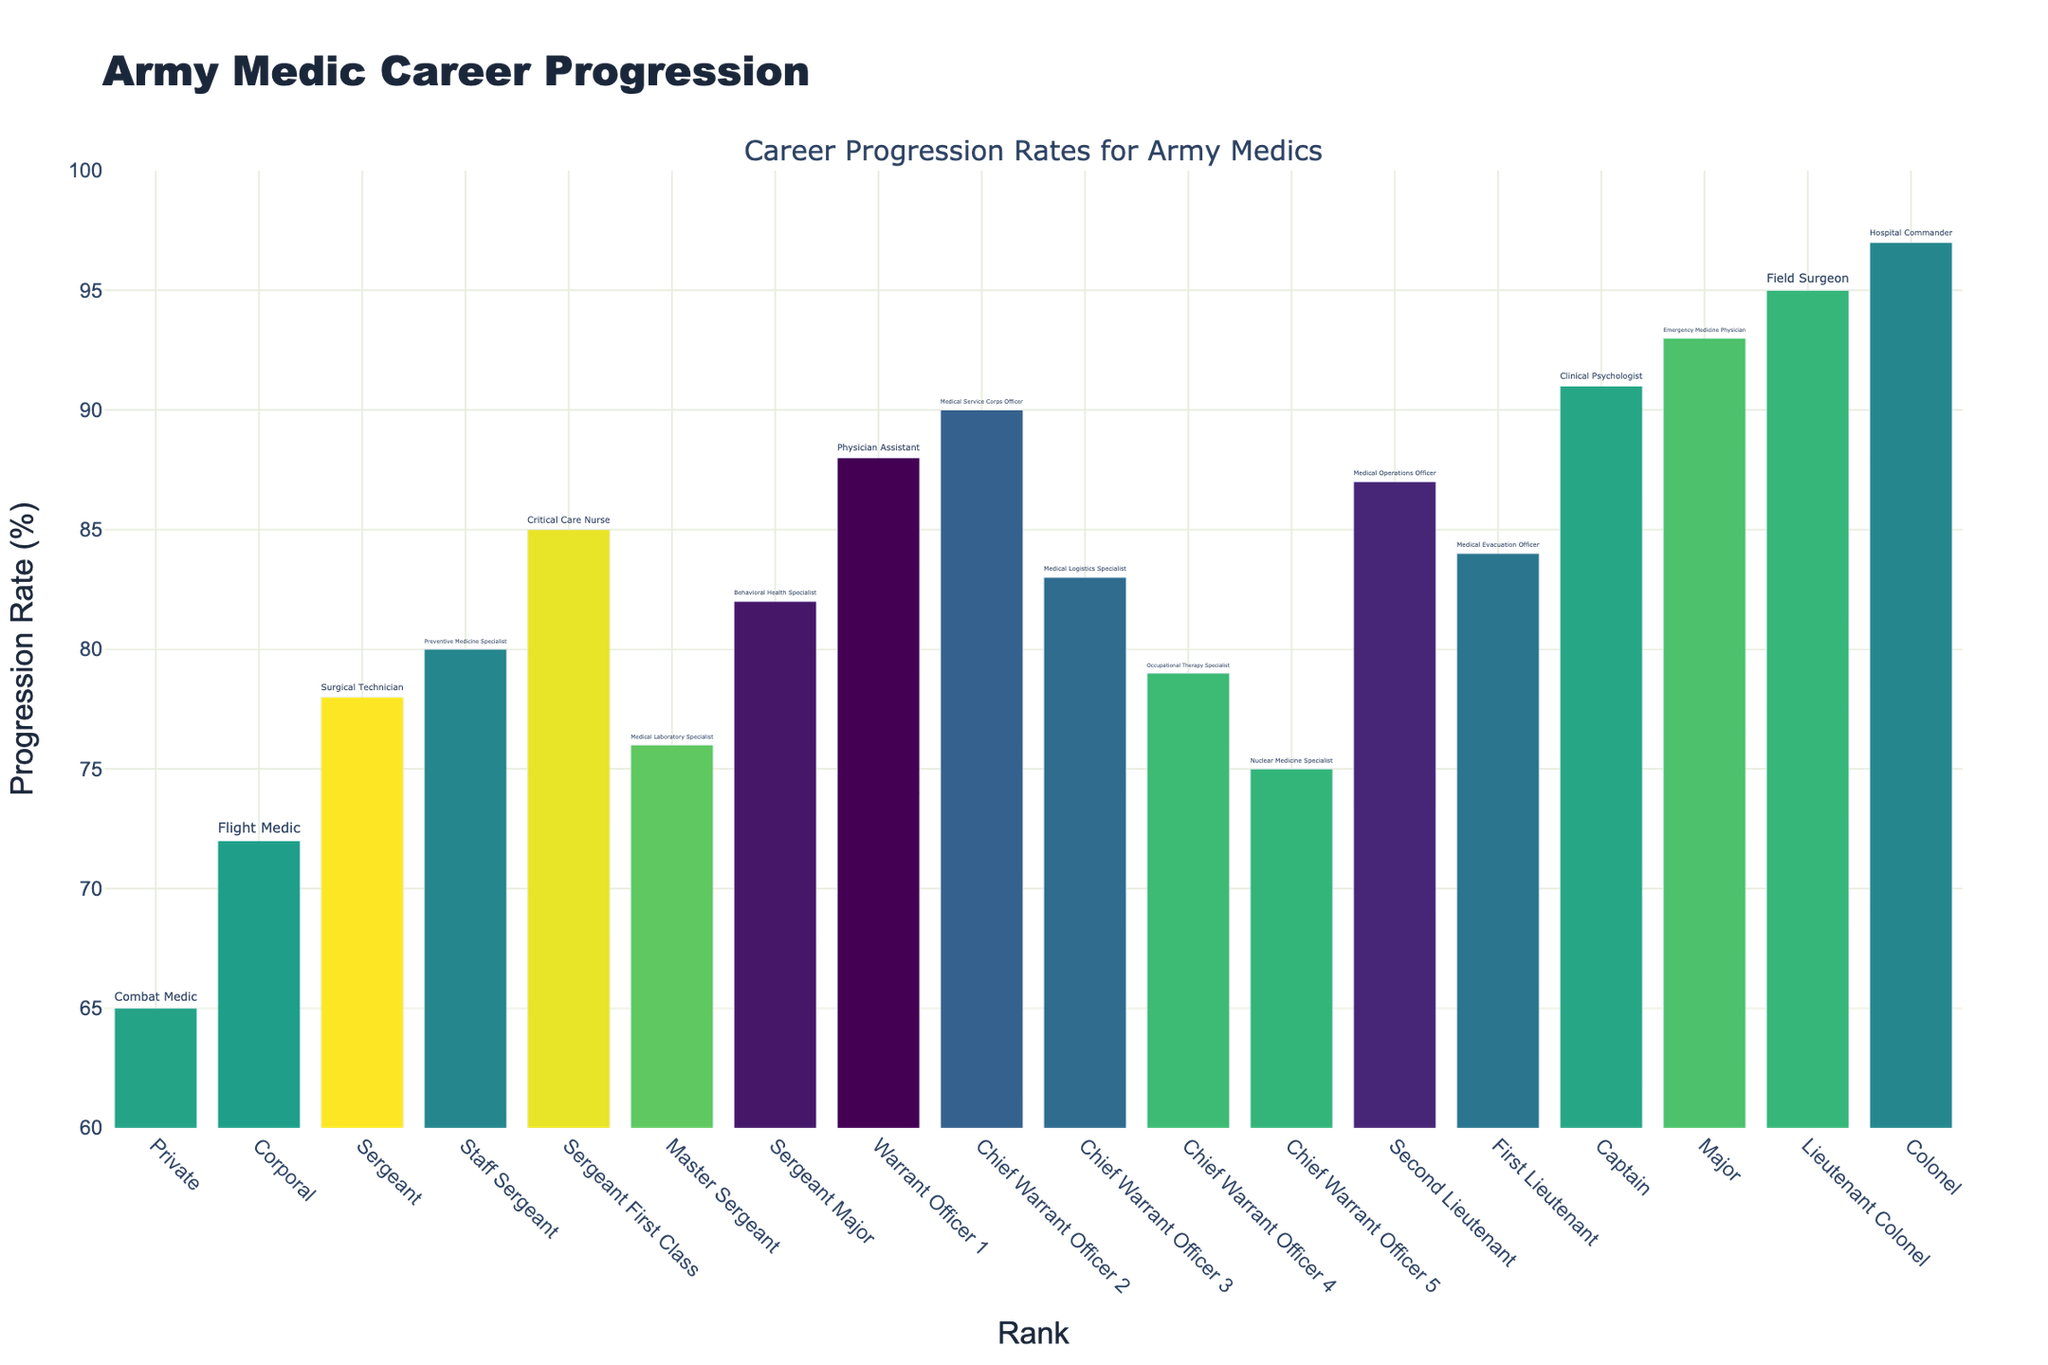Which rank has the highest progression rate? Identify the tallest bar in the chart. The highest rank, associated with the highest progression rate, is "Colonel" with a progression rate of 97%.
Answer: Colonel Which specialization has the lowest progression rate? Locate the shortest bar in the chart. The specialization "Combat Medic" has the lowest progression rate of 65%.
Answer: Combat Medic What is the average progression rate for Warrant Officer ranks? Calculate the average progression rate by adding the rates for Warrant Officer 1, Chief Warrant Officer 2, Chief Warrant Officer 3, Chief Warrant Officer 4, and Chief Warrant Officer 5, then dividing by 5: (88 + 90 + 83 + 79 + 75) / 5 = 83.
Answer: 83 How does the progression rate of a Sergeant Major compare to that of a Captain? Look at the progression rates of Sergeant Major and Captain. The progression rate for Sergeant Major (82%) is less than that for Captain (91%).
Answer: Less than How many ranks have a progression rate of 85% or higher? Count the bars with a progression rate of 85% or above: Critical Care Nurse (85%), Medical Service Corps Officer (90%), Medical Evacuation Officer (84%, but not 85% or higher), Clinical Psychologist (91%), Emergency Medicine Physician (93%), Field Surgeon (95%), and Hospital Commander (97%).
Answer: 6 What is the difference in progression rate between a Sergeant and a Second Lieutenant? Subtract the progression rate of a Sergeant (78%) from that of a Second Lieutenant (87%): 87 - 78 = 9.
Answer: 9 Which specialization in the Staff Sergeant rank has a higher progression rate than the Master Sergeant rank specialization? Compare the progression rates of Staff Sergeant's specialization (80%) and Master Sergeant's specialization (76%). Preventive Medicine Specialist at Staff Sergeant has a higher rate than Medical Laboratory Specialist at Master Sergeant.
Answer: Preventive Medicine Specialist Is the progression rate of a First Lieutenant greater than a Warrant Officer 1? Compare the progression rates of First Lieutenant (84%) and Warrant Officer 1 (88%). No, the First Lieutenant (84%) has a lower progression rate than Warrant Officer 1 (88%).
Answer: No Calculate the median progression rate for all the ranks displayed. First, list the progression rates in ascending order: 65, 72, 75, 76, 78, 79, 80, 82, 83, 84, 85, 87, 88, 90, 91, 93, 95, 97. The median is the middle value. Since there are 18 values, the median is the average of the 9th and 10th values: (83 + 84) / 2 = 83.5.
Answer: 83.5 